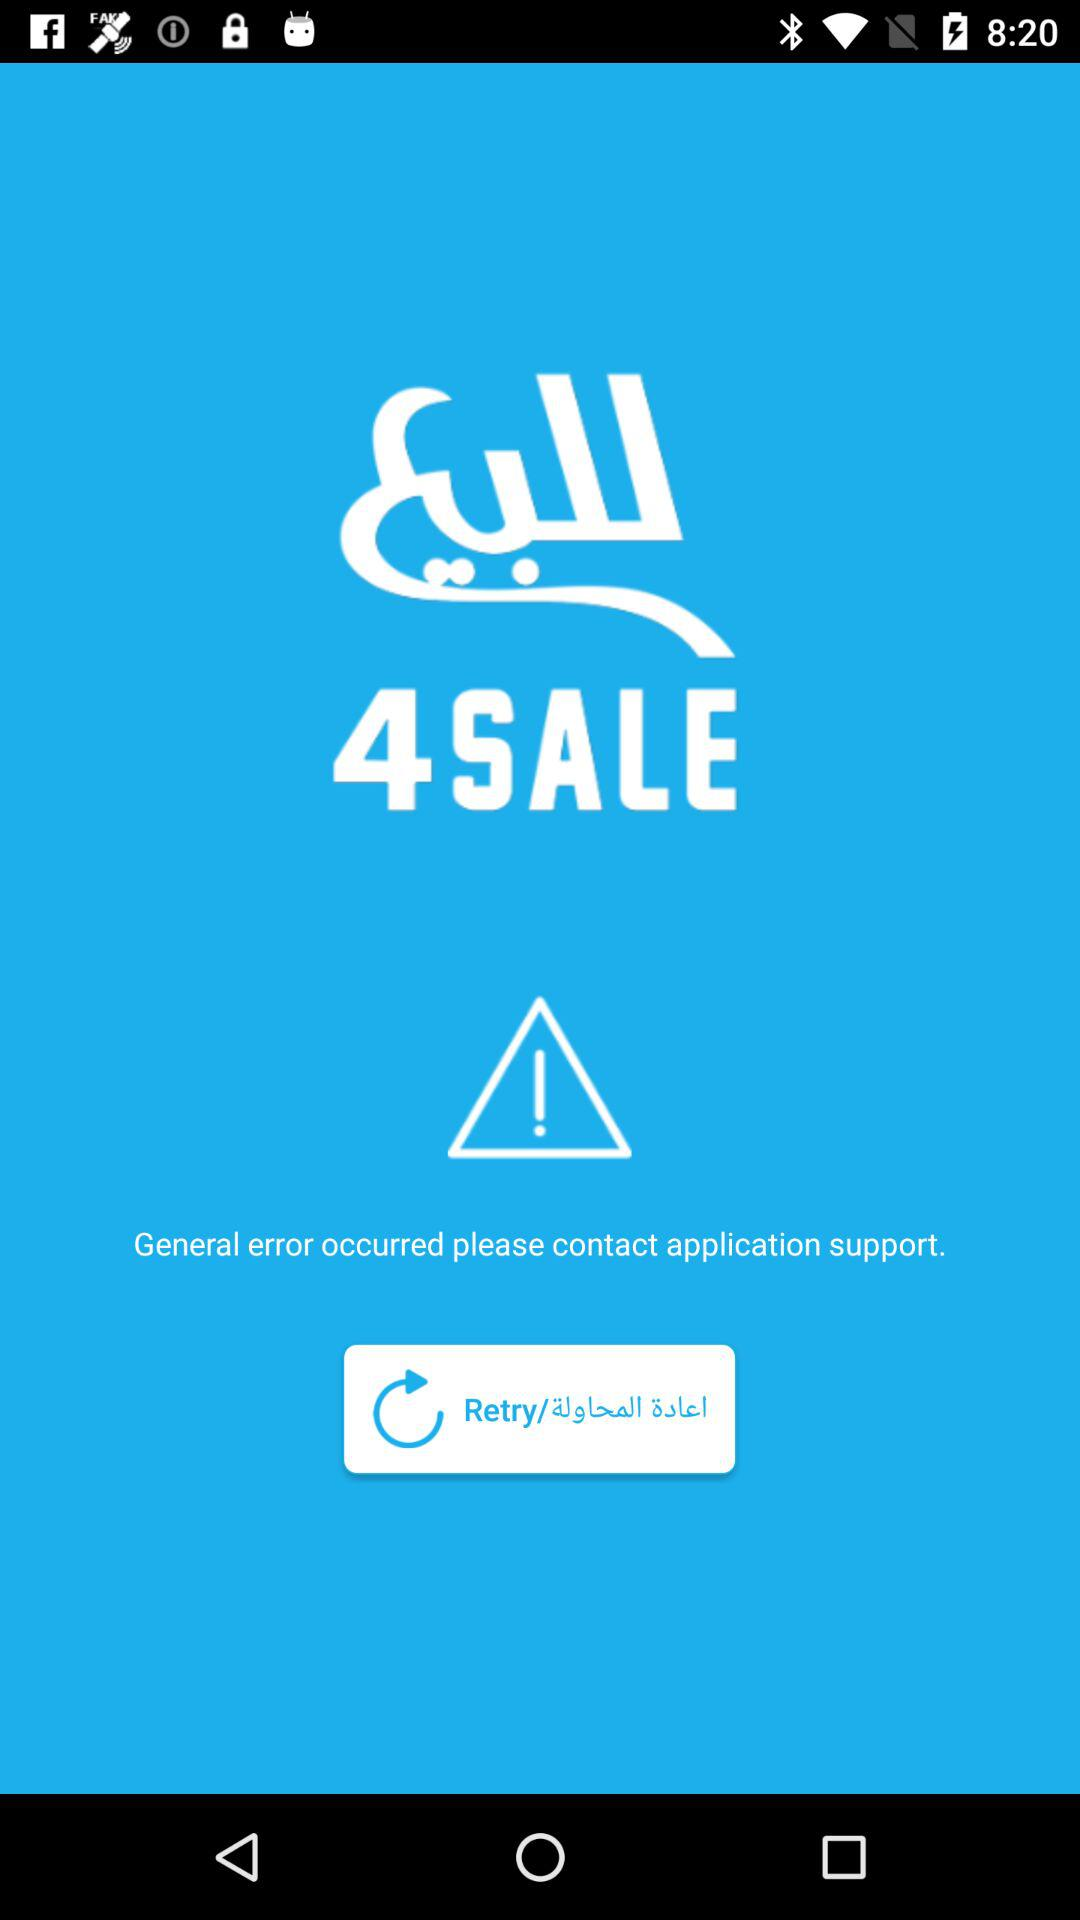What is the application name? The application name is "4SALE". 